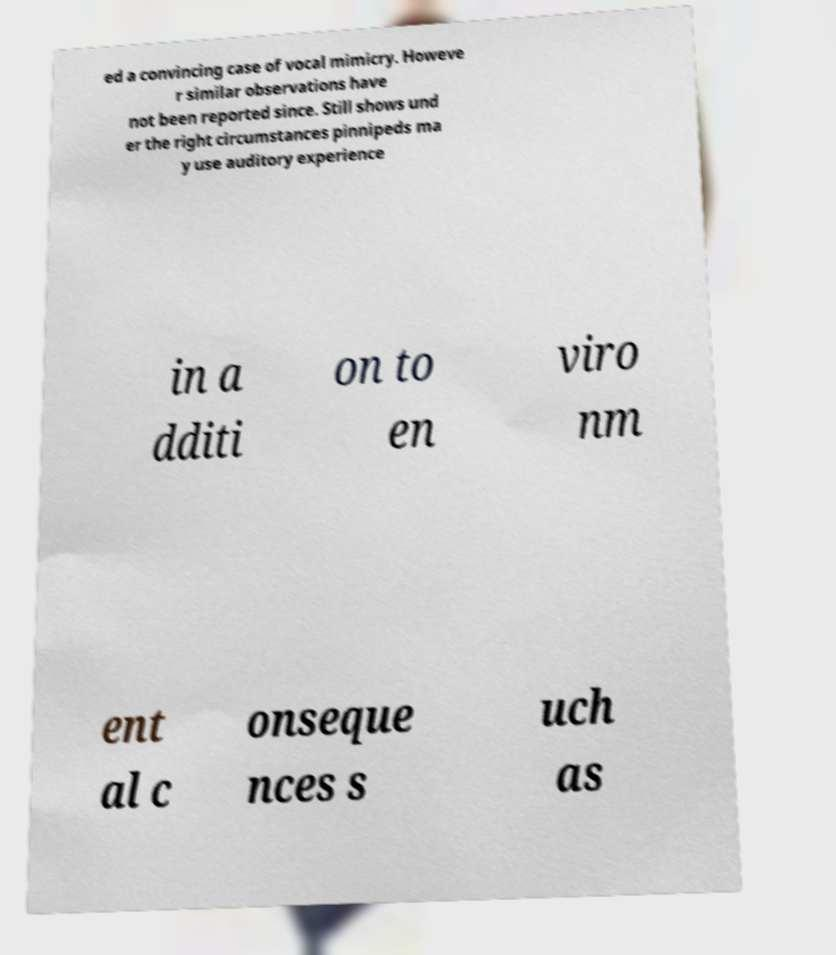Please read and relay the text visible in this image. What does it say? ed a convincing case of vocal mimicry. Howeve r similar observations have not been reported since. Still shows und er the right circumstances pinnipeds ma y use auditory experience in a dditi on to en viro nm ent al c onseque nces s uch as 